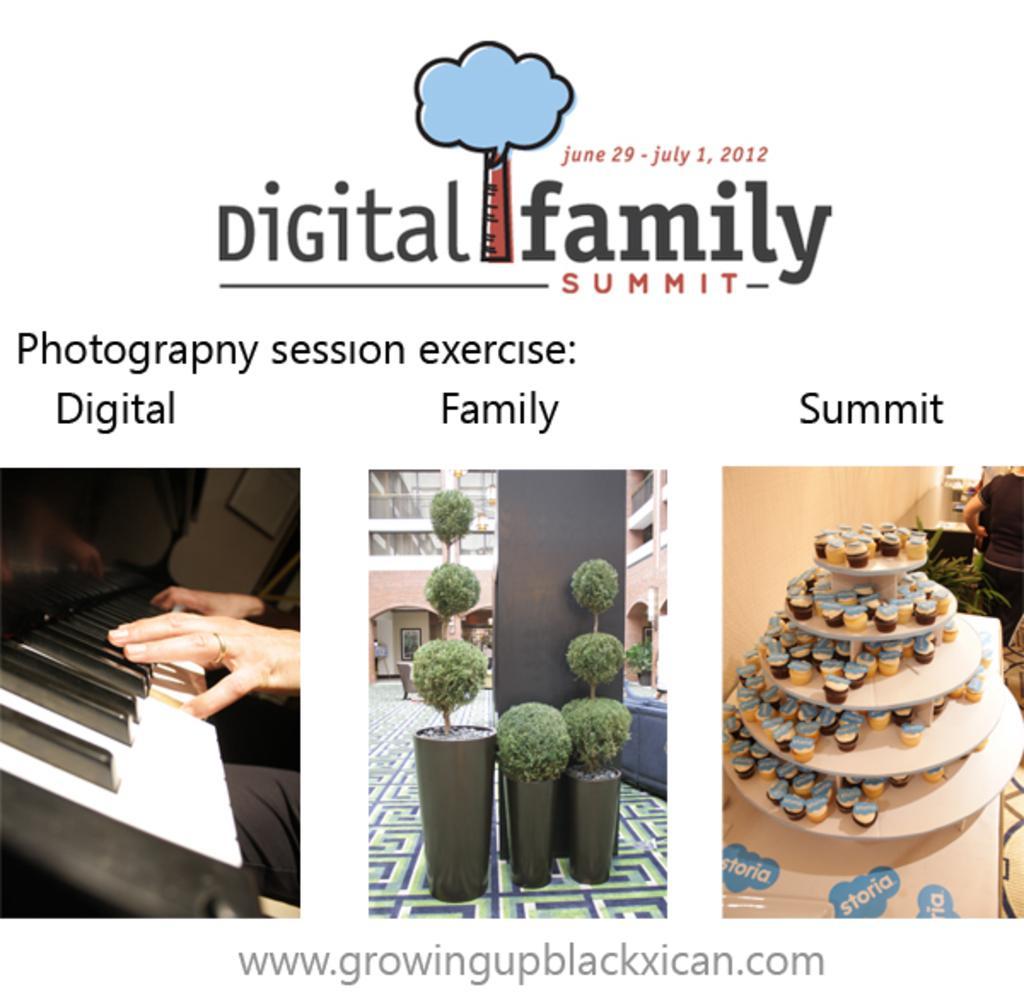Please provide a concise description of this image. In this picture there is a poster. In the poster I can see the three frames. In the center I can see pots, plants, pillar and buildings. On the right I can see the cups on the rack which is kept on the table. Beside that I can see some persons who are standing near to the wall. On the left I can see the person's hand who is playing a piano. At the bottom there is a watermark. 